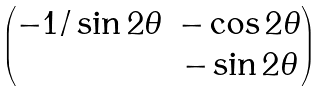Convert formula to latex. <formula><loc_0><loc_0><loc_500><loc_500>\begin{pmatrix} - 1 / \sin 2 \theta & - \cos 2 \theta \\ & - \sin 2 \theta \end{pmatrix}</formula> 